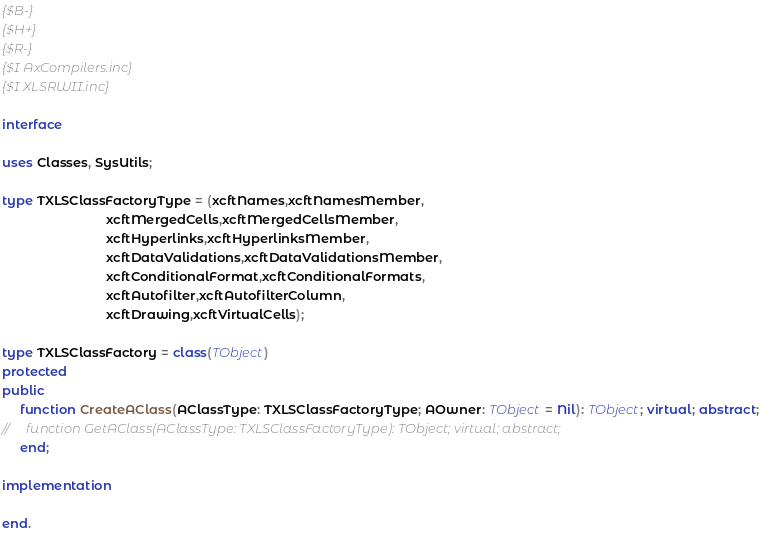Convert code to text. <code><loc_0><loc_0><loc_500><loc_500><_Pascal_>
{$B-}
{$H+}
{$R-}
{$I AxCompilers.inc}
{$I XLSRWII.inc}

interface

uses Classes, SysUtils;

type TXLSClassFactoryType = (xcftNames,xcftNamesMember,
                             xcftMergedCells,xcftMergedCellsMember,
                             xcftHyperlinks,xcftHyperlinksMember,
                             xcftDataValidations,xcftDataValidationsMember,
                             xcftConditionalFormat,xcftConditionalFormats,
                             xcftAutofilter,xcftAutofilterColumn,
                             xcftDrawing,xcftVirtualCells);

type TXLSClassFactory = class(TObject)
protected
public
     function CreateAClass(AClassType: TXLSClassFactoryType; AOwner: TObject = Nil): TObject; virtual; abstract;
//     function GetAClass(AClassType: TXLSClassFactoryType): TObject; virtual; abstract;
     end;

implementation

end.
</code> 